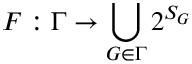Convert formula to latex. <formula><loc_0><loc_0><loc_500><loc_500>F \colon \Gamma \rightarrow \bigcup _ { G \in \Gamma } 2 ^ { S _ { G } }</formula> 